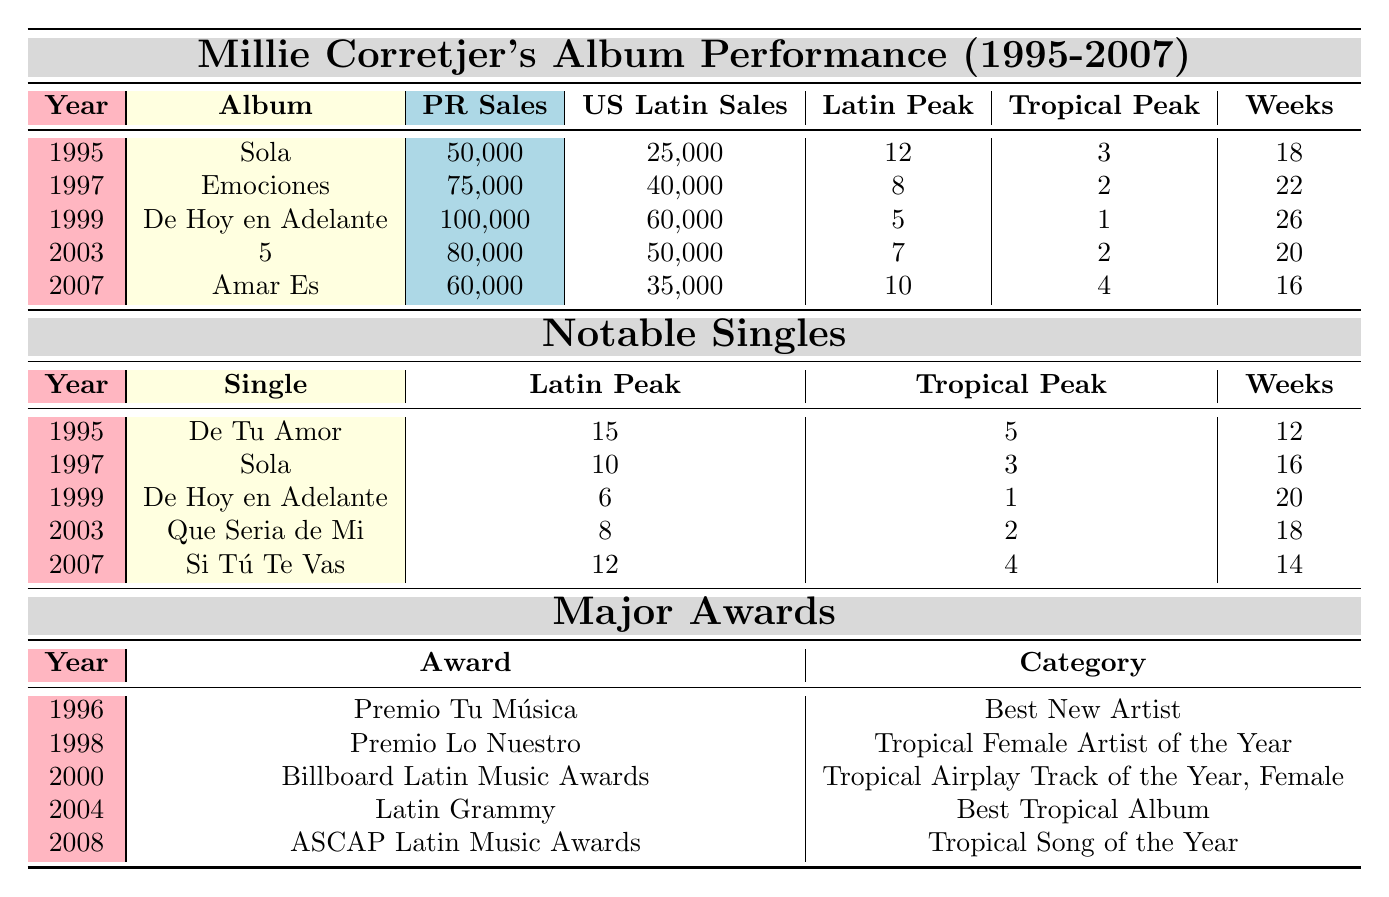What year did Millie Corretjer release "De Hoy en Adelante"? The title "De Hoy en Adelante" can be found in the album section of the table under the year 1999.
Answer: 1999 Which album had the highest sales in Puerto Rico? By looking at the Puerto Rican sales figures for each album, "De Hoy en Adelante" has the highest sales at 100,000 units.
Answer: De Hoy en Adelante What was the peak position on the Billboard Latin chart for the single "Sola"? In the singles section of the table, "Sola" peaked at position 10 on the Billboard Latin chart in 1997.
Answer: 10 How many weeks did the album "Emociones" stay on the charts? The table shows that "Emociones" spent 22 weeks on the charts.
Answer: 22 weeks What is the total number of sales in the US Latin market for all albums combined? To find the total US Latin sales, add each album's sales: 25,000 (Sola) + 40,000 (Emociones) + 60,000 (De Hoy en Adelante) + 50,000 (5) + 35,000 (Amar Es) = 210,000.
Answer: 210,000 Did Millie Corretjer win any awards before 2000? Looking at the awards section, the first award listed, the "Premio Tu Música," was received in 1996, indicating that she did receive awards before 2000.
Answer: Yes Which album was released most recently? The last album listed is "Amar Es," released in 2007, which is the most recent album in the table.
Answer: Amar Es What is the difference in peak positions between the album "5" and the single "Que Seria de Mi"? "5" peaked at position 7 on the Billboard Latin chart, while "Que Seria de Mi" peaked at position 8. The difference between them is 1 position.
Answer: 1 position Which award did Millie Corretjer win in 2004? In the table, it's shown that she won the Latin Grammy award in 2004 for "Best Tropical Album."
Answer: Latin Grammy What was Millie's best performance in terms of weeks on the Billboard Tropical chart? To determine this, compare tropical peak weeks across the albums and singles; "De Hoy en Adelante" had the best peak at position 1 for weeks of 26.
Answer: 26 weeks 